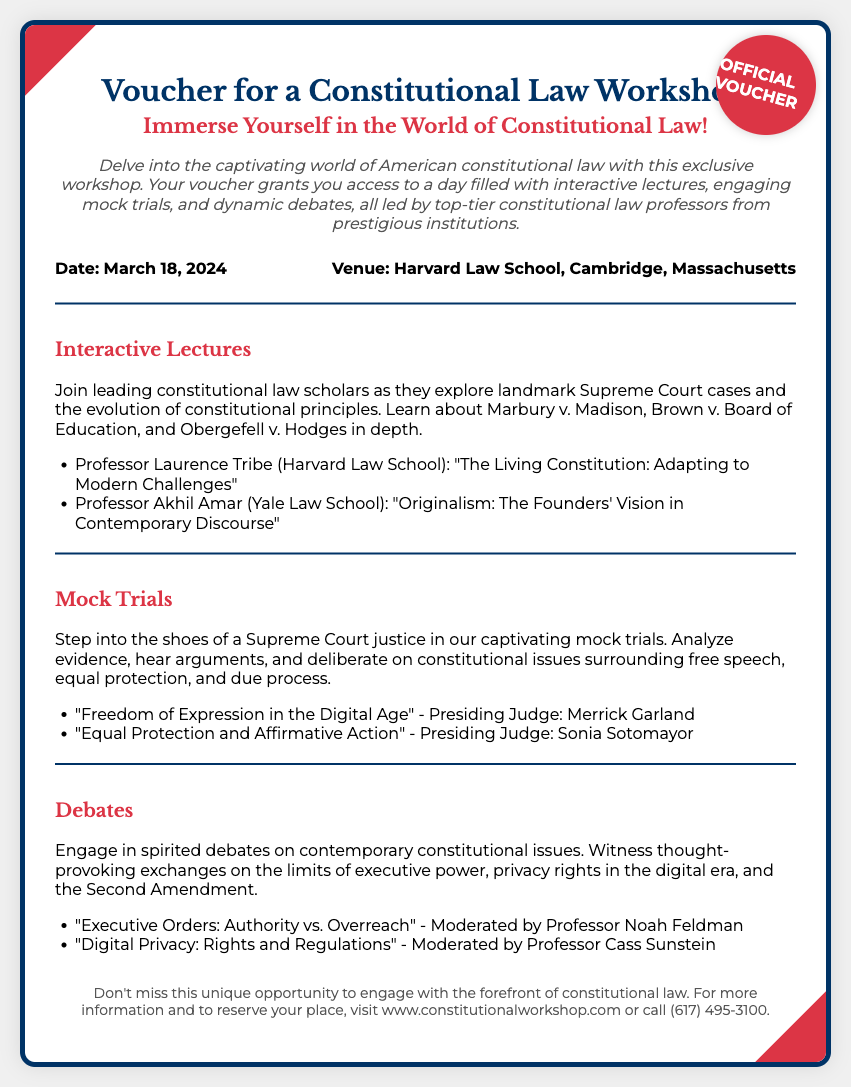What is the date of the workshop? The date of the workshop is specified in the document as March 18, 2024.
Answer: March 18, 2024 Where is the workshop being held? The venue for the workshop is mentioned as Harvard Law School, Cambridge, Massachusetts.
Answer: Harvard Law School, Cambridge, Massachusetts Who is presenting the lecture on "The Living Constitution: Adapting to Modern Challenges"? The document lists Professor Laurence Tribe from Harvard Law School as the presenter for this lecture.
Answer: Professor Laurence Tribe What is one of the mocked trials focused on? The document states that one mock trial is titled "Freedom of Expression in the Digital Age."
Answer: Freedom of Expression in the Digital Age Who will moderate the debate on "Digital Privacy: Rights and Regulations"? Professor Cass Sunstein is mentioned as the moderator for this debate in the document.
Answer: Professor Cass Sunstein What type of activities does this workshop include? The document describes the activities in the workshop as interactive lectures, mock trials, and debates.
Answer: Interactive lectures, mock trials, and debates What is the purpose of this voucher? The voucher grants access to a workshop focused on constitutional law.
Answer: Access to a workshop focused on constitutional law What organization could you contact for more information? The document suggests visiting www.constitutionalworkshop.com or calling (617) 495-3100 for more information.
Answer: www.constitutionalworkshop.com or (617) 495-3100 